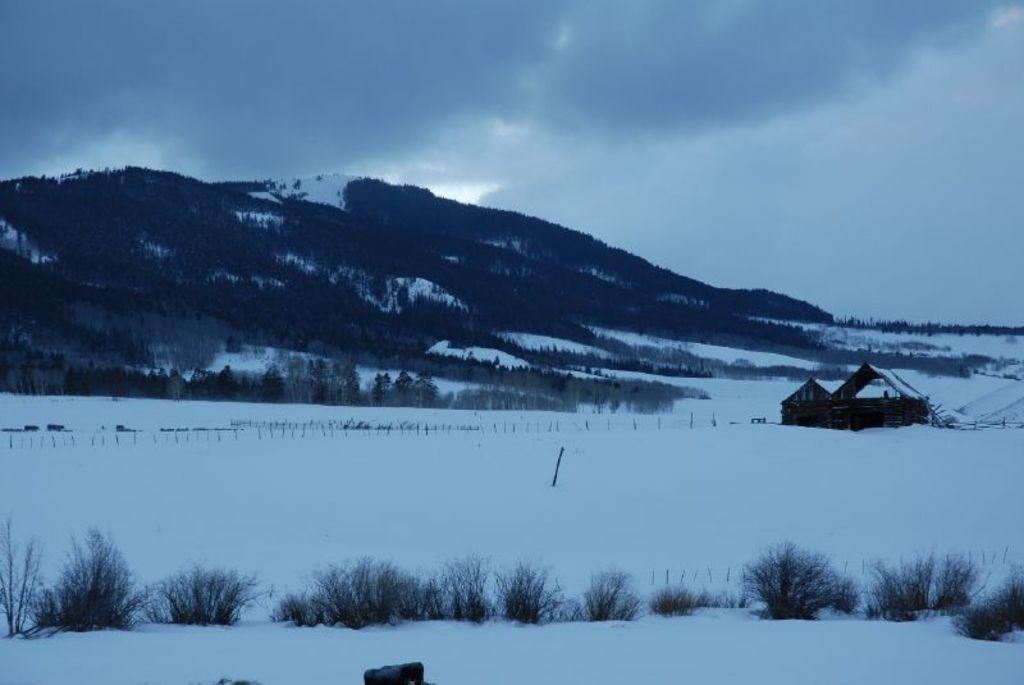What is present at the bottom of the picture? There is ice and grass at the bottom of the picture. What structure can be seen on the right side of the picture? There is a wooden hut on the right side of the picture. What can be seen in the background of the picture? There are trees and hills in the background of the picture. What is visible at the top of the picture? The sky is visible at the top of the picture. How many passengers are visible in the wooden hut? There are no passengers present in the wooden hut; it is a structure and not a mode of transportation. What type of tree is growing on the left side of the picture? There is no tree growing on the left side of the picture; only ice, grass, and the wooden hut are present. 